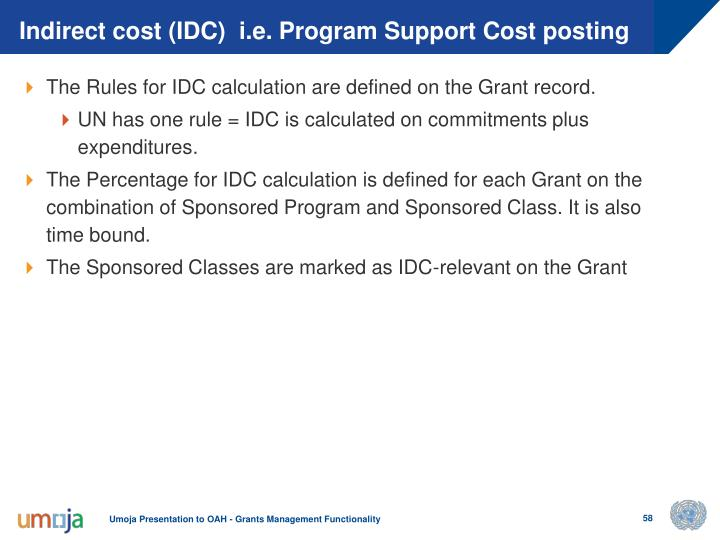How important is it to understand and adhere to the definitions and rules presented in grant management slides? It's vital to understand and adhere to the definitions and rules presented in grant management slides as these form the backbone of effective grant administration. They ensure that both the funding body and the receiving institution are aligned in their financial practices, reducing the risk of discrepancies during audits. The clarity and accuracy in these definitions help prevent legal or financial noncompliance issues which could lead to penalties, fund recovery, or damage to reputation. 